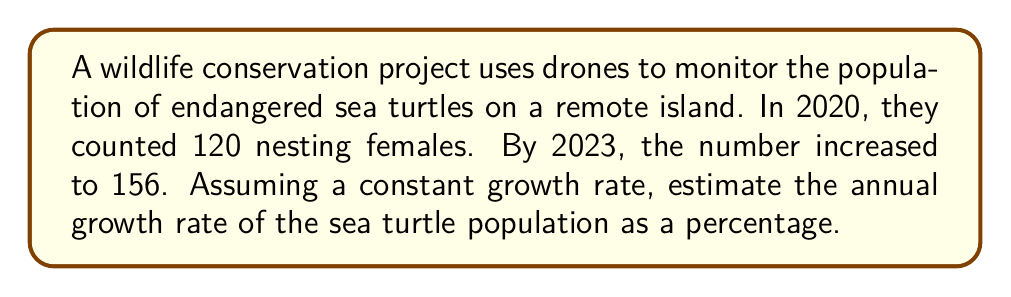Help me with this question. Let's approach this step-by-step:

1) First, we need to calculate the total growth rate over the 3-year period:
   
   Growth rate = $\frac{\text{New Value} - \text{Original Value}}{\text{Original Value}}$
   
   $$ \text{Total Growth Rate} = \frac{156 - 120}{120} = \frac{36}{120} = 0.3 = 30\% $$

2) Now, we need to find the annual growth rate. Since the growth is over 3 years, we can use the following equation:

   $$(1 + r)^3 = 1.3$$

   Where $r$ is the annual growth rate we're looking for.

3) To solve for $r$, we can take the cube root of both sides:

   $$\sqrt[3]{(1 + r)^3} = \sqrt[3]{1.3}$$
   
   $$1 + r = \sqrt[3]{1.3}$$

4) Subtract 1 from both sides:

   $$r = \sqrt[3]{1.3} - 1 \approx 1.0914 - 1 = 0.0914$$

5) Convert to a percentage:

   $$0.0914 \times 100\% = 9.14\%$$

Therefore, the estimated annual growth rate is approximately 9.14%.
Answer: 9.14% 